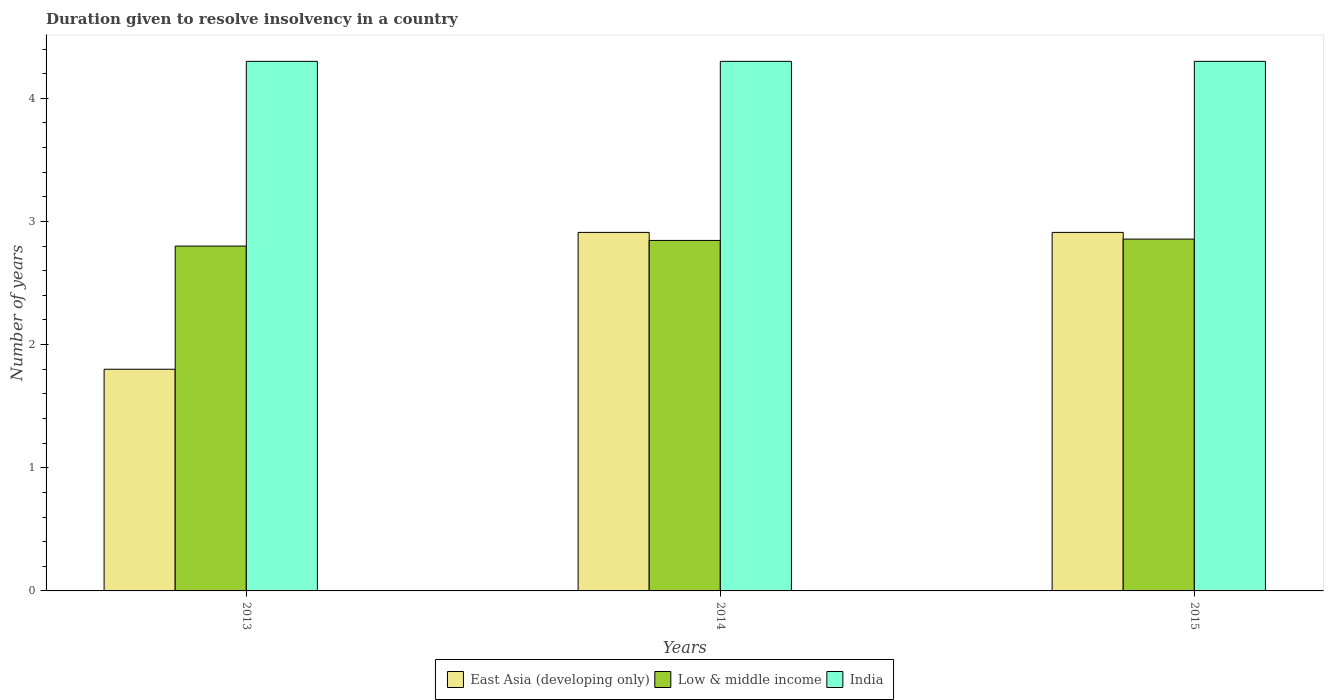How many different coloured bars are there?
Keep it short and to the point. 3. Are the number of bars per tick equal to the number of legend labels?
Make the answer very short. Yes. Are the number of bars on each tick of the X-axis equal?
Your answer should be very brief. Yes. What is the duration given to resolve insolvency in in Low & middle income in 2015?
Make the answer very short. 2.86. Across all years, what is the maximum duration given to resolve insolvency in in East Asia (developing only)?
Offer a very short reply. 2.91. In which year was the duration given to resolve insolvency in in Low & middle income maximum?
Ensure brevity in your answer.  2015. In which year was the duration given to resolve insolvency in in East Asia (developing only) minimum?
Make the answer very short. 2013. What is the total duration given to resolve insolvency in in Low & middle income in the graph?
Your response must be concise. 8.5. What is the difference between the duration given to resolve insolvency in in East Asia (developing only) in 2013 and that in 2014?
Provide a succinct answer. -1.11. What is the difference between the duration given to resolve insolvency in in Low & middle income in 2014 and the duration given to resolve insolvency in in East Asia (developing only) in 2013?
Your answer should be compact. 1.05. What is the average duration given to resolve insolvency in in India per year?
Make the answer very short. 4.3. In the year 2015, what is the difference between the duration given to resolve insolvency in in Low & middle income and duration given to resolve insolvency in in India?
Your response must be concise. -1.44. What is the ratio of the duration given to resolve insolvency in in East Asia (developing only) in 2014 to that in 2015?
Your response must be concise. 1. What is the difference between the highest and the lowest duration given to resolve insolvency in in East Asia (developing only)?
Offer a very short reply. 1.11. In how many years, is the duration given to resolve insolvency in in Low & middle income greater than the average duration given to resolve insolvency in in Low & middle income taken over all years?
Your answer should be very brief. 2. Is the sum of the duration given to resolve insolvency in in India in 2014 and 2015 greater than the maximum duration given to resolve insolvency in in Low & middle income across all years?
Offer a terse response. Yes. What does the 1st bar from the left in 2015 represents?
Provide a short and direct response. East Asia (developing only). Is it the case that in every year, the sum of the duration given to resolve insolvency in in India and duration given to resolve insolvency in in Low & middle income is greater than the duration given to resolve insolvency in in East Asia (developing only)?
Keep it short and to the point. Yes. How many bars are there?
Your answer should be very brief. 9. Are the values on the major ticks of Y-axis written in scientific E-notation?
Make the answer very short. No. Where does the legend appear in the graph?
Your response must be concise. Bottom center. How many legend labels are there?
Offer a terse response. 3. How are the legend labels stacked?
Make the answer very short. Horizontal. What is the title of the graph?
Give a very brief answer. Duration given to resolve insolvency in a country. What is the label or title of the Y-axis?
Make the answer very short. Number of years. What is the Number of years in East Asia (developing only) in 2013?
Offer a very short reply. 1.8. What is the Number of years of Low & middle income in 2013?
Provide a short and direct response. 2.8. What is the Number of years of India in 2013?
Ensure brevity in your answer.  4.3. What is the Number of years in East Asia (developing only) in 2014?
Your answer should be compact. 2.91. What is the Number of years in Low & middle income in 2014?
Offer a terse response. 2.85. What is the Number of years of East Asia (developing only) in 2015?
Ensure brevity in your answer.  2.91. What is the Number of years of Low & middle income in 2015?
Ensure brevity in your answer.  2.86. Across all years, what is the maximum Number of years of East Asia (developing only)?
Offer a very short reply. 2.91. Across all years, what is the maximum Number of years in Low & middle income?
Give a very brief answer. 2.86. Across all years, what is the maximum Number of years of India?
Keep it short and to the point. 4.3. Across all years, what is the minimum Number of years of East Asia (developing only)?
Keep it short and to the point. 1.8. Across all years, what is the minimum Number of years of Low & middle income?
Provide a succinct answer. 2.8. What is the total Number of years in East Asia (developing only) in the graph?
Keep it short and to the point. 7.62. What is the total Number of years in Low & middle income in the graph?
Give a very brief answer. 8.5. What is the total Number of years of India in the graph?
Your response must be concise. 12.9. What is the difference between the Number of years in East Asia (developing only) in 2013 and that in 2014?
Offer a terse response. -1.11. What is the difference between the Number of years of Low & middle income in 2013 and that in 2014?
Provide a succinct answer. -0.05. What is the difference between the Number of years of India in 2013 and that in 2014?
Ensure brevity in your answer.  0. What is the difference between the Number of years in East Asia (developing only) in 2013 and that in 2015?
Provide a succinct answer. -1.11. What is the difference between the Number of years of Low & middle income in 2013 and that in 2015?
Provide a short and direct response. -0.06. What is the difference between the Number of years of Low & middle income in 2014 and that in 2015?
Provide a succinct answer. -0.01. What is the difference between the Number of years in India in 2014 and that in 2015?
Your answer should be compact. 0. What is the difference between the Number of years of East Asia (developing only) in 2013 and the Number of years of Low & middle income in 2014?
Your answer should be very brief. -1.05. What is the difference between the Number of years of East Asia (developing only) in 2013 and the Number of years of India in 2014?
Your answer should be compact. -2.5. What is the difference between the Number of years of Low & middle income in 2013 and the Number of years of India in 2014?
Provide a short and direct response. -1.5. What is the difference between the Number of years in East Asia (developing only) in 2013 and the Number of years in Low & middle income in 2015?
Make the answer very short. -1.06. What is the difference between the Number of years in East Asia (developing only) in 2013 and the Number of years in India in 2015?
Give a very brief answer. -2.5. What is the difference between the Number of years of Low & middle income in 2013 and the Number of years of India in 2015?
Your answer should be very brief. -1.5. What is the difference between the Number of years of East Asia (developing only) in 2014 and the Number of years of Low & middle income in 2015?
Provide a short and direct response. 0.05. What is the difference between the Number of years of East Asia (developing only) in 2014 and the Number of years of India in 2015?
Make the answer very short. -1.39. What is the difference between the Number of years in Low & middle income in 2014 and the Number of years in India in 2015?
Your answer should be compact. -1.45. What is the average Number of years in East Asia (developing only) per year?
Your answer should be compact. 2.54. What is the average Number of years of Low & middle income per year?
Ensure brevity in your answer.  2.83. In the year 2013, what is the difference between the Number of years in East Asia (developing only) and Number of years in Low & middle income?
Ensure brevity in your answer.  -1. In the year 2014, what is the difference between the Number of years in East Asia (developing only) and Number of years in Low & middle income?
Ensure brevity in your answer.  0.07. In the year 2014, what is the difference between the Number of years in East Asia (developing only) and Number of years in India?
Your answer should be compact. -1.39. In the year 2014, what is the difference between the Number of years of Low & middle income and Number of years of India?
Provide a short and direct response. -1.45. In the year 2015, what is the difference between the Number of years in East Asia (developing only) and Number of years in Low & middle income?
Make the answer very short. 0.05. In the year 2015, what is the difference between the Number of years in East Asia (developing only) and Number of years in India?
Provide a succinct answer. -1.39. In the year 2015, what is the difference between the Number of years of Low & middle income and Number of years of India?
Make the answer very short. -1.44. What is the ratio of the Number of years in East Asia (developing only) in 2013 to that in 2014?
Give a very brief answer. 0.62. What is the ratio of the Number of years of Low & middle income in 2013 to that in 2014?
Give a very brief answer. 0.98. What is the ratio of the Number of years in East Asia (developing only) in 2013 to that in 2015?
Your answer should be compact. 0.62. What is the ratio of the Number of years of Low & middle income in 2013 to that in 2015?
Offer a terse response. 0.98. What is the ratio of the Number of years of East Asia (developing only) in 2014 to that in 2015?
Your response must be concise. 1. What is the ratio of the Number of years in Low & middle income in 2014 to that in 2015?
Provide a short and direct response. 1. What is the ratio of the Number of years in India in 2014 to that in 2015?
Ensure brevity in your answer.  1. What is the difference between the highest and the second highest Number of years of East Asia (developing only)?
Provide a short and direct response. 0. What is the difference between the highest and the second highest Number of years of Low & middle income?
Provide a succinct answer. 0.01. What is the difference between the highest and the second highest Number of years of India?
Your answer should be compact. 0. What is the difference between the highest and the lowest Number of years in East Asia (developing only)?
Offer a terse response. 1.11. What is the difference between the highest and the lowest Number of years of Low & middle income?
Your response must be concise. 0.06. 